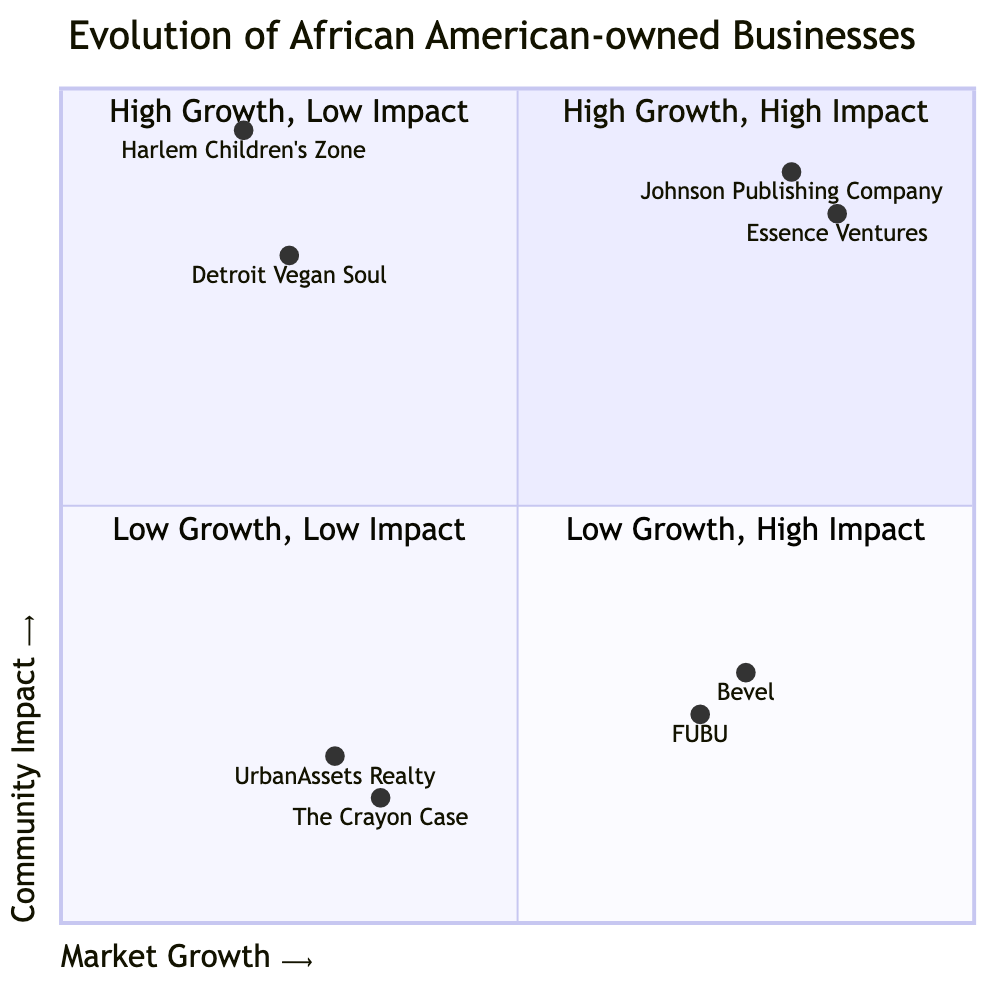What businesses fall in the High Growth, High Impact quadrant? The High Growth, High Impact quadrant contains Johnson Publishing Company and Essence Ventures. These businesses are described as having strong financial success and significant positive effects on the community.
Answer: Johnson Publishing Company, Essence Ventures How many businesses are in the Low Growth, Low Impact quadrant? There are two businesses in the Low Growth, Low Impact quadrant: UrbanAssets Realty and The Crayon Case. This quadrant indicates limited market success and minimal community influence.
Answer: 2 Which business has the highest community impact in the Low Growth, High Impact quadrant? The business with the highest community impact in the Low Growth, High Impact quadrant is Harlem Children's Zone, as it is dedicated to providing educational and social services, highlighting its deep community engagement.
Answer: Harlem Children's Zone What is the market growth level of FUBU? FUBU is categorized as having high market growth in the High Growth, Low Impact quadrant, indicating significant commercial success though it has fewer community programs.
Answer: High Which quadrant has businesses with limited market success and minimal community influence? The Low Growth, Low Impact quadrant contains businesses with limited market success and minimal community influence, specifically represented by UrbanAssets Realty and The Crayon Case.
Answer: Low Growth, Low Impact What is the community impact level of Bevel? Bevel has a low community impact level, as indicated in the High Growth, Low Impact quadrant where it shows strong market performance yet limited direct community initiatives.
Answer: Low Which business is positioned closest to the origin (0,0)? The Crayon Case is positioned closest to the origin (0,0), indicating it has low market growth and low community impact, according to its coordinates in the Low Growth, Low Impact quadrant.
Answer: The Crayon Case What does the High Growth, Low Impact quadrant indicate about Bevel? The High Growth, Low Impact quadrant indicates that Bevel shows substantial financial growth but is lesser-known for direct community influence, as it has strong market performance with limited community initiatives.
Answer: Substantial financial growth, lesser-known community influence 